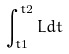Convert formula to latex. <formula><loc_0><loc_0><loc_500><loc_500>\int _ { t 1 } ^ { t 2 } L d t</formula> 